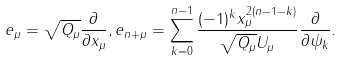<formula> <loc_0><loc_0><loc_500><loc_500>e _ { \mu } = \sqrt { Q _ { \mu } } \frac { \partial } { \partial x _ { \mu } } , e _ { n + \mu } = \sum _ { k = 0 } ^ { n - 1 } \frac { ( - 1 ) ^ { k } x _ { \mu } ^ { 2 ( n - 1 - k ) } } { \sqrt { Q _ { \mu } } U _ { \mu } } \frac { \partial } { \partial \psi _ { k } } .</formula> 